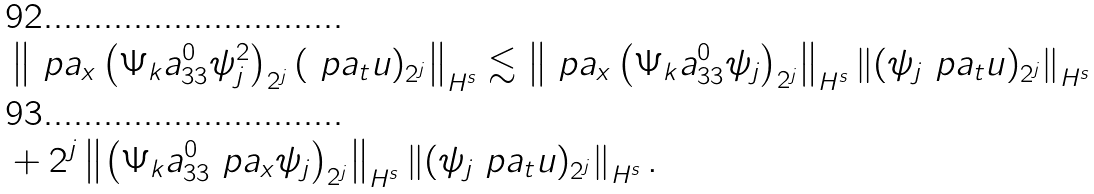<formula> <loc_0><loc_0><loc_500><loc_500>& \left \| \ p a _ { x } \left ( \Psi _ { k } { a } _ { 3 3 } ^ { 0 } \psi _ { j } ^ { 2 } \right ) _ { 2 ^ { j } } ( \ p a _ { t } u ) _ { 2 ^ { j } } \right \| _ { H ^ { s } } \lesssim \left \| \ p a _ { x } \left ( \Psi _ { k } { a } _ { 3 3 } ^ { 0 } \psi _ { j } \right ) _ { 2 ^ { j } } \right \| _ { H ^ { s } } \left \| ( \psi _ { j } \ p a _ { t } u ) _ { 2 ^ { j } } \right \| _ { H ^ { s } } \\ & + 2 ^ { j } \left \| \left ( \Psi _ { k } { a } _ { 3 3 } ^ { 0 } \ p a _ { x } \psi _ { j } \right ) _ { 2 ^ { j } } \right \| _ { H ^ { s } } \left \| ( \psi _ { j } \ p a _ { t } u ) _ { 2 ^ { j } } \right \| _ { H ^ { s } } .</formula> 